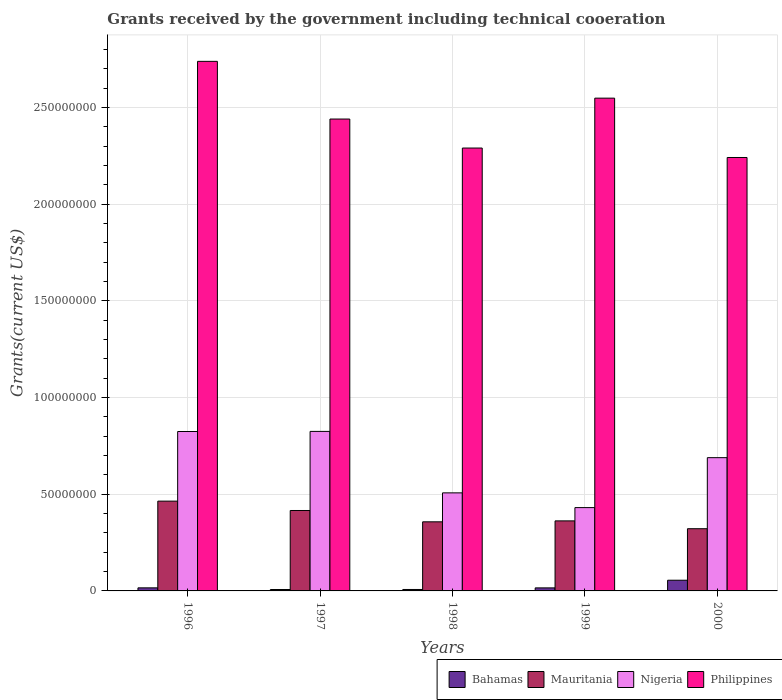How many groups of bars are there?
Provide a short and direct response. 5. Are the number of bars on each tick of the X-axis equal?
Ensure brevity in your answer.  Yes. How many bars are there on the 5th tick from the left?
Your answer should be compact. 4. How many bars are there on the 1st tick from the right?
Your answer should be very brief. 4. What is the label of the 1st group of bars from the left?
Give a very brief answer. 1996. What is the total grants received by the government in Mauritania in 1998?
Offer a terse response. 3.57e+07. Across all years, what is the maximum total grants received by the government in Mauritania?
Offer a very short reply. 4.64e+07. Across all years, what is the minimum total grants received by the government in Nigeria?
Keep it short and to the point. 4.31e+07. In which year was the total grants received by the government in Philippines maximum?
Ensure brevity in your answer.  1996. In which year was the total grants received by the government in Bahamas minimum?
Ensure brevity in your answer.  1997. What is the total total grants received by the government in Nigeria in the graph?
Offer a very short reply. 3.28e+08. What is the difference between the total grants received by the government in Mauritania in 1997 and that in 1999?
Provide a succinct answer. 5.37e+06. What is the difference between the total grants received by the government in Mauritania in 1998 and the total grants received by the government in Philippines in 1996?
Your response must be concise. -2.38e+08. What is the average total grants received by the government in Philippines per year?
Offer a very short reply. 2.45e+08. In the year 1996, what is the difference between the total grants received by the government in Bahamas and total grants received by the government in Mauritania?
Ensure brevity in your answer.  -4.48e+07. What is the ratio of the total grants received by the government in Mauritania in 1996 to that in 1998?
Provide a succinct answer. 1.3. Is the total grants received by the government in Philippines in 1996 less than that in 1999?
Provide a short and direct response. No. What is the difference between the highest and the second highest total grants received by the government in Bahamas?
Give a very brief answer. 3.94e+06. What is the difference between the highest and the lowest total grants received by the government in Bahamas?
Your response must be concise. 4.80e+06. Is the sum of the total grants received by the government in Bahamas in 1997 and 1999 greater than the maximum total grants received by the government in Nigeria across all years?
Ensure brevity in your answer.  No. Is it the case that in every year, the sum of the total grants received by the government in Mauritania and total grants received by the government in Bahamas is greater than the sum of total grants received by the government in Nigeria and total grants received by the government in Philippines?
Offer a terse response. No. What does the 3rd bar from the left in 1998 represents?
Make the answer very short. Nigeria. What does the 2nd bar from the right in 1998 represents?
Your answer should be compact. Nigeria. Are all the bars in the graph horizontal?
Keep it short and to the point. No. How many years are there in the graph?
Make the answer very short. 5. Are the values on the major ticks of Y-axis written in scientific E-notation?
Your answer should be very brief. No. How many legend labels are there?
Keep it short and to the point. 4. What is the title of the graph?
Provide a short and direct response. Grants received by the government including technical cooeration. Does "Solomon Islands" appear as one of the legend labels in the graph?
Your response must be concise. No. What is the label or title of the X-axis?
Give a very brief answer. Years. What is the label or title of the Y-axis?
Your answer should be very brief. Grants(current US$). What is the Grants(current US$) in Bahamas in 1996?
Your answer should be compact. 1.59e+06. What is the Grants(current US$) in Mauritania in 1996?
Keep it short and to the point. 4.64e+07. What is the Grants(current US$) of Nigeria in 1996?
Your response must be concise. 8.25e+07. What is the Grants(current US$) of Philippines in 1996?
Your answer should be very brief. 2.74e+08. What is the Grants(current US$) of Bahamas in 1997?
Make the answer very short. 7.30e+05. What is the Grants(current US$) in Mauritania in 1997?
Ensure brevity in your answer.  4.16e+07. What is the Grants(current US$) of Nigeria in 1997?
Provide a succinct answer. 8.25e+07. What is the Grants(current US$) in Philippines in 1997?
Provide a short and direct response. 2.44e+08. What is the Grants(current US$) of Bahamas in 1998?
Ensure brevity in your answer.  7.50e+05. What is the Grants(current US$) of Mauritania in 1998?
Your answer should be very brief. 3.57e+07. What is the Grants(current US$) of Nigeria in 1998?
Offer a very short reply. 5.07e+07. What is the Grants(current US$) of Philippines in 1998?
Your answer should be compact. 2.29e+08. What is the Grants(current US$) in Bahamas in 1999?
Offer a terse response. 1.57e+06. What is the Grants(current US$) of Mauritania in 1999?
Offer a terse response. 3.62e+07. What is the Grants(current US$) of Nigeria in 1999?
Give a very brief answer. 4.31e+07. What is the Grants(current US$) of Philippines in 1999?
Offer a terse response. 2.55e+08. What is the Grants(current US$) in Bahamas in 2000?
Your answer should be compact. 5.53e+06. What is the Grants(current US$) in Mauritania in 2000?
Your answer should be very brief. 3.22e+07. What is the Grants(current US$) of Nigeria in 2000?
Keep it short and to the point. 6.89e+07. What is the Grants(current US$) of Philippines in 2000?
Give a very brief answer. 2.24e+08. Across all years, what is the maximum Grants(current US$) of Bahamas?
Offer a very short reply. 5.53e+06. Across all years, what is the maximum Grants(current US$) of Mauritania?
Offer a terse response. 4.64e+07. Across all years, what is the maximum Grants(current US$) of Nigeria?
Ensure brevity in your answer.  8.25e+07. Across all years, what is the maximum Grants(current US$) of Philippines?
Your response must be concise. 2.74e+08. Across all years, what is the minimum Grants(current US$) in Bahamas?
Provide a succinct answer. 7.30e+05. Across all years, what is the minimum Grants(current US$) in Mauritania?
Your answer should be compact. 3.22e+07. Across all years, what is the minimum Grants(current US$) of Nigeria?
Give a very brief answer. 4.31e+07. Across all years, what is the minimum Grants(current US$) in Philippines?
Offer a very short reply. 2.24e+08. What is the total Grants(current US$) of Bahamas in the graph?
Offer a terse response. 1.02e+07. What is the total Grants(current US$) in Mauritania in the graph?
Make the answer very short. 1.92e+08. What is the total Grants(current US$) in Nigeria in the graph?
Your answer should be compact. 3.28e+08. What is the total Grants(current US$) of Philippines in the graph?
Your response must be concise. 1.23e+09. What is the difference between the Grants(current US$) of Bahamas in 1996 and that in 1997?
Give a very brief answer. 8.60e+05. What is the difference between the Grants(current US$) of Mauritania in 1996 and that in 1997?
Offer a very short reply. 4.84e+06. What is the difference between the Grants(current US$) in Nigeria in 1996 and that in 1997?
Provide a succinct answer. -5.00e+04. What is the difference between the Grants(current US$) of Philippines in 1996 and that in 1997?
Make the answer very short. 2.98e+07. What is the difference between the Grants(current US$) in Bahamas in 1996 and that in 1998?
Your answer should be compact. 8.40e+05. What is the difference between the Grants(current US$) in Mauritania in 1996 and that in 1998?
Your answer should be compact. 1.07e+07. What is the difference between the Grants(current US$) in Nigeria in 1996 and that in 1998?
Provide a succinct answer. 3.17e+07. What is the difference between the Grants(current US$) in Philippines in 1996 and that in 1998?
Offer a terse response. 4.48e+07. What is the difference between the Grants(current US$) of Mauritania in 1996 and that in 1999?
Your answer should be very brief. 1.02e+07. What is the difference between the Grants(current US$) of Nigeria in 1996 and that in 1999?
Give a very brief answer. 3.94e+07. What is the difference between the Grants(current US$) of Philippines in 1996 and that in 1999?
Your response must be concise. 1.90e+07. What is the difference between the Grants(current US$) in Bahamas in 1996 and that in 2000?
Make the answer very short. -3.94e+06. What is the difference between the Grants(current US$) of Mauritania in 1996 and that in 2000?
Make the answer very short. 1.43e+07. What is the difference between the Grants(current US$) in Nigeria in 1996 and that in 2000?
Provide a succinct answer. 1.35e+07. What is the difference between the Grants(current US$) in Philippines in 1996 and that in 2000?
Your response must be concise. 4.97e+07. What is the difference between the Grants(current US$) of Mauritania in 1997 and that in 1998?
Your answer should be very brief. 5.86e+06. What is the difference between the Grants(current US$) in Nigeria in 1997 and that in 1998?
Provide a succinct answer. 3.18e+07. What is the difference between the Grants(current US$) of Philippines in 1997 and that in 1998?
Your answer should be compact. 1.50e+07. What is the difference between the Grants(current US$) of Bahamas in 1997 and that in 1999?
Your response must be concise. -8.40e+05. What is the difference between the Grants(current US$) in Mauritania in 1997 and that in 1999?
Offer a terse response. 5.37e+06. What is the difference between the Grants(current US$) of Nigeria in 1997 and that in 1999?
Provide a short and direct response. 3.94e+07. What is the difference between the Grants(current US$) in Philippines in 1997 and that in 1999?
Ensure brevity in your answer.  -1.08e+07. What is the difference between the Grants(current US$) of Bahamas in 1997 and that in 2000?
Your answer should be compact. -4.80e+06. What is the difference between the Grants(current US$) of Mauritania in 1997 and that in 2000?
Provide a succinct answer. 9.42e+06. What is the difference between the Grants(current US$) in Nigeria in 1997 and that in 2000?
Ensure brevity in your answer.  1.36e+07. What is the difference between the Grants(current US$) of Philippines in 1997 and that in 2000?
Ensure brevity in your answer.  1.99e+07. What is the difference between the Grants(current US$) in Bahamas in 1998 and that in 1999?
Offer a very short reply. -8.20e+05. What is the difference between the Grants(current US$) in Mauritania in 1998 and that in 1999?
Make the answer very short. -4.90e+05. What is the difference between the Grants(current US$) of Nigeria in 1998 and that in 1999?
Your answer should be very brief. 7.62e+06. What is the difference between the Grants(current US$) in Philippines in 1998 and that in 1999?
Your response must be concise. -2.58e+07. What is the difference between the Grants(current US$) of Bahamas in 1998 and that in 2000?
Your response must be concise. -4.78e+06. What is the difference between the Grants(current US$) in Mauritania in 1998 and that in 2000?
Provide a succinct answer. 3.56e+06. What is the difference between the Grants(current US$) of Nigeria in 1998 and that in 2000?
Give a very brief answer. -1.82e+07. What is the difference between the Grants(current US$) in Philippines in 1998 and that in 2000?
Make the answer very short. 4.89e+06. What is the difference between the Grants(current US$) of Bahamas in 1999 and that in 2000?
Provide a succinct answer. -3.96e+06. What is the difference between the Grants(current US$) in Mauritania in 1999 and that in 2000?
Offer a terse response. 4.05e+06. What is the difference between the Grants(current US$) of Nigeria in 1999 and that in 2000?
Offer a very short reply. -2.58e+07. What is the difference between the Grants(current US$) in Philippines in 1999 and that in 2000?
Give a very brief answer. 3.07e+07. What is the difference between the Grants(current US$) in Bahamas in 1996 and the Grants(current US$) in Mauritania in 1997?
Give a very brief answer. -4.00e+07. What is the difference between the Grants(current US$) in Bahamas in 1996 and the Grants(current US$) in Nigeria in 1997?
Your response must be concise. -8.09e+07. What is the difference between the Grants(current US$) in Bahamas in 1996 and the Grants(current US$) in Philippines in 1997?
Give a very brief answer. -2.42e+08. What is the difference between the Grants(current US$) of Mauritania in 1996 and the Grants(current US$) of Nigeria in 1997?
Make the answer very short. -3.61e+07. What is the difference between the Grants(current US$) of Mauritania in 1996 and the Grants(current US$) of Philippines in 1997?
Offer a terse response. -1.98e+08. What is the difference between the Grants(current US$) in Nigeria in 1996 and the Grants(current US$) in Philippines in 1997?
Your answer should be very brief. -1.62e+08. What is the difference between the Grants(current US$) of Bahamas in 1996 and the Grants(current US$) of Mauritania in 1998?
Your answer should be very brief. -3.42e+07. What is the difference between the Grants(current US$) in Bahamas in 1996 and the Grants(current US$) in Nigeria in 1998?
Ensure brevity in your answer.  -4.91e+07. What is the difference between the Grants(current US$) of Bahamas in 1996 and the Grants(current US$) of Philippines in 1998?
Provide a short and direct response. -2.27e+08. What is the difference between the Grants(current US$) in Mauritania in 1996 and the Grants(current US$) in Nigeria in 1998?
Ensure brevity in your answer.  -4.28e+06. What is the difference between the Grants(current US$) in Mauritania in 1996 and the Grants(current US$) in Philippines in 1998?
Provide a short and direct response. -1.83e+08. What is the difference between the Grants(current US$) of Nigeria in 1996 and the Grants(current US$) of Philippines in 1998?
Keep it short and to the point. -1.47e+08. What is the difference between the Grants(current US$) of Bahamas in 1996 and the Grants(current US$) of Mauritania in 1999?
Offer a very short reply. -3.46e+07. What is the difference between the Grants(current US$) in Bahamas in 1996 and the Grants(current US$) in Nigeria in 1999?
Provide a succinct answer. -4.15e+07. What is the difference between the Grants(current US$) in Bahamas in 1996 and the Grants(current US$) in Philippines in 1999?
Your answer should be compact. -2.53e+08. What is the difference between the Grants(current US$) of Mauritania in 1996 and the Grants(current US$) of Nigeria in 1999?
Make the answer very short. 3.34e+06. What is the difference between the Grants(current US$) in Mauritania in 1996 and the Grants(current US$) in Philippines in 1999?
Offer a very short reply. -2.08e+08. What is the difference between the Grants(current US$) in Nigeria in 1996 and the Grants(current US$) in Philippines in 1999?
Your answer should be compact. -1.72e+08. What is the difference between the Grants(current US$) of Bahamas in 1996 and the Grants(current US$) of Mauritania in 2000?
Give a very brief answer. -3.06e+07. What is the difference between the Grants(current US$) in Bahamas in 1996 and the Grants(current US$) in Nigeria in 2000?
Offer a terse response. -6.73e+07. What is the difference between the Grants(current US$) of Bahamas in 1996 and the Grants(current US$) of Philippines in 2000?
Provide a short and direct response. -2.23e+08. What is the difference between the Grants(current US$) in Mauritania in 1996 and the Grants(current US$) in Nigeria in 2000?
Give a very brief answer. -2.25e+07. What is the difference between the Grants(current US$) in Mauritania in 1996 and the Grants(current US$) in Philippines in 2000?
Your answer should be very brief. -1.78e+08. What is the difference between the Grants(current US$) of Nigeria in 1996 and the Grants(current US$) of Philippines in 2000?
Your answer should be very brief. -1.42e+08. What is the difference between the Grants(current US$) of Bahamas in 1997 and the Grants(current US$) of Mauritania in 1998?
Ensure brevity in your answer.  -3.50e+07. What is the difference between the Grants(current US$) in Bahamas in 1997 and the Grants(current US$) in Nigeria in 1998?
Provide a succinct answer. -5.00e+07. What is the difference between the Grants(current US$) in Bahamas in 1997 and the Grants(current US$) in Philippines in 1998?
Make the answer very short. -2.28e+08. What is the difference between the Grants(current US$) in Mauritania in 1997 and the Grants(current US$) in Nigeria in 1998?
Offer a very short reply. -9.12e+06. What is the difference between the Grants(current US$) of Mauritania in 1997 and the Grants(current US$) of Philippines in 1998?
Provide a short and direct response. -1.87e+08. What is the difference between the Grants(current US$) in Nigeria in 1997 and the Grants(current US$) in Philippines in 1998?
Provide a short and direct response. -1.47e+08. What is the difference between the Grants(current US$) in Bahamas in 1997 and the Grants(current US$) in Mauritania in 1999?
Ensure brevity in your answer.  -3.55e+07. What is the difference between the Grants(current US$) in Bahamas in 1997 and the Grants(current US$) in Nigeria in 1999?
Make the answer very short. -4.24e+07. What is the difference between the Grants(current US$) of Bahamas in 1997 and the Grants(current US$) of Philippines in 1999?
Give a very brief answer. -2.54e+08. What is the difference between the Grants(current US$) in Mauritania in 1997 and the Grants(current US$) in Nigeria in 1999?
Provide a succinct answer. -1.50e+06. What is the difference between the Grants(current US$) in Mauritania in 1997 and the Grants(current US$) in Philippines in 1999?
Offer a terse response. -2.13e+08. What is the difference between the Grants(current US$) in Nigeria in 1997 and the Grants(current US$) in Philippines in 1999?
Your answer should be very brief. -1.72e+08. What is the difference between the Grants(current US$) of Bahamas in 1997 and the Grants(current US$) of Mauritania in 2000?
Your response must be concise. -3.14e+07. What is the difference between the Grants(current US$) of Bahamas in 1997 and the Grants(current US$) of Nigeria in 2000?
Your response must be concise. -6.82e+07. What is the difference between the Grants(current US$) in Bahamas in 1997 and the Grants(current US$) in Philippines in 2000?
Your answer should be very brief. -2.23e+08. What is the difference between the Grants(current US$) in Mauritania in 1997 and the Grants(current US$) in Nigeria in 2000?
Give a very brief answer. -2.73e+07. What is the difference between the Grants(current US$) in Mauritania in 1997 and the Grants(current US$) in Philippines in 2000?
Offer a terse response. -1.83e+08. What is the difference between the Grants(current US$) of Nigeria in 1997 and the Grants(current US$) of Philippines in 2000?
Provide a succinct answer. -1.42e+08. What is the difference between the Grants(current US$) of Bahamas in 1998 and the Grants(current US$) of Mauritania in 1999?
Offer a very short reply. -3.55e+07. What is the difference between the Grants(current US$) in Bahamas in 1998 and the Grants(current US$) in Nigeria in 1999?
Offer a very short reply. -4.24e+07. What is the difference between the Grants(current US$) of Bahamas in 1998 and the Grants(current US$) of Philippines in 1999?
Your answer should be compact. -2.54e+08. What is the difference between the Grants(current US$) in Mauritania in 1998 and the Grants(current US$) in Nigeria in 1999?
Provide a short and direct response. -7.36e+06. What is the difference between the Grants(current US$) of Mauritania in 1998 and the Grants(current US$) of Philippines in 1999?
Offer a very short reply. -2.19e+08. What is the difference between the Grants(current US$) in Nigeria in 1998 and the Grants(current US$) in Philippines in 1999?
Your response must be concise. -2.04e+08. What is the difference between the Grants(current US$) in Bahamas in 1998 and the Grants(current US$) in Mauritania in 2000?
Offer a terse response. -3.14e+07. What is the difference between the Grants(current US$) in Bahamas in 1998 and the Grants(current US$) in Nigeria in 2000?
Offer a terse response. -6.82e+07. What is the difference between the Grants(current US$) of Bahamas in 1998 and the Grants(current US$) of Philippines in 2000?
Provide a short and direct response. -2.23e+08. What is the difference between the Grants(current US$) in Mauritania in 1998 and the Grants(current US$) in Nigeria in 2000?
Ensure brevity in your answer.  -3.32e+07. What is the difference between the Grants(current US$) in Mauritania in 1998 and the Grants(current US$) in Philippines in 2000?
Keep it short and to the point. -1.88e+08. What is the difference between the Grants(current US$) of Nigeria in 1998 and the Grants(current US$) of Philippines in 2000?
Ensure brevity in your answer.  -1.73e+08. What is the difference between the Grants(current US$) in Bahamas in 1999 and the Grants(current US$) in Mauritania in 2000?
Keep it short and to the point. -3.06e+07. What is the difference between the Grants(current US$) of Bahamas in 1999 and the Grants(current US$) of Nigeria in 2000?
Your answer should be compact. -6.74e+07. What is the difference between the Grants(current US$) in Bahamas in 1999 and the Grants(current US$) in Philippines in 2000?
Ensure brevity in your answer.  -2.23e+08. What is the difference between the Grants(current US$) in Mauritania in 1999 and the Grants(current US$) in Nigeria in 2000?
Offer a terse response. -3.27e+07. What is the difference between the Grants(current US$) in Mauritania in 1999 and the Grants(current US$) in Philippines in 2000?
Ensure brevity in your answer.  -1.88e+08. What is the difference between the Grants(current US$) of Nigeria in 1999 and the Grants(current US$) of Philippines in 2000?
Offer a very short reply. -1.81e+08. What is the average Grants(current US$) of Bahamas per year?
Make the answer very short. 2.03e+06. What is the average Grants(current US$) in Mauritania per year?
Make the answer very short. 3.84e+07. What is the average Grants(current US$) in Nigeria per year?
Provide a succinct answer. 6.55e+07. What is the average Grants(current US$) in Philippines per year?
Keep it short and to the point. 2.45e+08. In the year 1996, what is the difference between the Grants(current US$) of Bahamas and Grants(current US$) of Mauritania?
Your answer should be compact. -4.48e+07. In the year 1996, what is the difference between the Grants(current US$) of Bahamas and Grants(current US$) of Nigeria?
Provide a succinct answer. -8.09e+07. In the year 1996, what is the difference between the Grants(current US$) in Bahamas and Grants(current US$) in Philippines?
Offer a terse response. -2.72e+08. In the year 1996, what is the difference between the Grants(current US$) of Mauritania and Grants(current US$) of Nigeria?
Make the answer very short. -3.60e+07. In the year 1996, what is the difference between the Grants(current US$) in Mauritania and Grants(current US$) in Philippines?
Provide a succinct answer. -2.27e+08. In the year 1996, what is the difference between the Grants(current US$) in Nigeria and Grants(current US$) in Philippines?
Keep it short and to the point. -1.91e+08. In the year 1997, what is the difference between the Grants(current US$) of Bahamas and Grants(current US$) of Mauritania?
Provide a short and direct response. -4.09e+07. In the year 1997, what is the difference between the Grants(current US$) in Bahamas and Grants(current US$) in Nigeria?
Provide a short and direct response. -8.18e+07. In the year 1997, what is the difference between the Grants(current US$) of Bahamas and Grants(current US$) of Philippines?
Ensure brevity in your answer.  -2.43e+08. In the year 1997, what is the difference between the Grants(current US$) of Mauritania and Grants(current US$) of Nigeria?
Offer a very short reply. -4.09e+07. In the year 1997, what is the difference between the Grants(current US$) of Mauritania and Grants(current US$) of Philippines?
Give a very brief answer. -2.02e+08. In the year 1997, what is the difference between the Grants(current US$) in Nigeria and Grants(current US$) in Philippines?
Your answer should be compact. -1.62e+08. In the year 1998, what is the difference between the Grants(current US$) of Bahamas and Grants(current US$) of Mauritania?
Your answer should be compact. -3.50e+07. In the year 1998, what is the difference between the Grants(current US$) of Bahamas and Grants(current US$) of Nigeria?
Provide a succinct answer. -5.00e+07. In the year 1998, what is the difference between the Grants(current US$) of Bahamas and Grants(current US$) of Philippines?
Provide a succinct answer. -2.28e+08. In the year 1998, what is the difference between the Grants(current US$) in Mauritania and Grants(current US$) in Nigeria?
Your response must be concise. -1.50e+07. In the year 1998, what is the difference between the Grants(current US$) of Mauritania and Grants(current US$) of Philippines?
Ensure brevity in your answer.  -1.93e+08. In the year 1998, what is the difference between the Grants(current US$) in Nigeria and Grants(current US$) in Philippines?
Provide a succinct answer. -1.78e+08. In the year 1999, what is the difference between the Grants(current US$) of Bahamas and Grants(current US$) of Mauritania?
Ensure brevity in your answer.  -3.47e+07. In the year 1999, what is the difference between the Grants(current US$) of Bahamas and Grants(current US$) of Nigeria?
Your answer should be compact. -4.15e+07. In the year 1999, what is the difference between the Grants(current US$) in Bahamas and Grants(current US$) in Philippines?
Offer a terse response. -2.53e+08. In the year 1999, what is the difference between the Grants(current US$) in Mauritania and Grants(current US$) in Nigeria?
Keep it short and to the point. -6.87e+06. In the year 1999, what is the difference between the Grants(current US$) in Mauritania and Grants(current US$) in Philippines?
Offer a very short reply. -2.19e+08. In the year 1999, what is the difference between the Grants(current US$) in Nigeria and Grants(current US$) in Philippines?
Your answer should be compact. -2.12e+08. In the year 2000, what is the difference between the Grants(current US$) of Bahamas and Grants(current US$) of Mauritania?
Offer a terse response. -2.66e+07. In the year 2000, what is the difference between the Grants(current US$) of Bahamas and Grants(current US$) of Nigeria?
Give a very brief answer. -6.34e+07. In the year 2000, what is the difference between the Grants(current US$) of Bahamas and Grants(current US$) of Philippines?
Provide a short and direct response. -2.19e+08. In the year 2000, what is the difference between the Grants(current US$) of Mauritania and Grants(current US$) of Nigeria?
Ensure brevity in your answer.  -3.68e+07. In the year 2000, what is the difference between the Grants(current US$) of Mauritania and Grants(current US$) of Philippines?
Your answer should be very brief. -1.92e+08. In the year 2000, what is the difference between the Grants(current US$) in Nigeria and Grants(current US$) in Philippines?
Make the answer very short. -1.55e+08. What is the ratio of the Grants(current US$) of Bahamas in 1996 to that in 1997?
Provide a succinct answer. 2.18. What is the ratio of the Grants(current US$) in Mauritania in 1996 to that in 1997?
Offer a very short reply. 1.12. What is the ratio of the Grants(current US$) of Philippines in 1996 to that in 1997?
Your answer should be very brief. 1.12. What is the ratio of the Grants(current US$) in Bahamas in 1996 to that in 1998?
Your answer should be compact. 2.12. What is the ratio of the Grants(current US$) of Mauritania in 1996 to that in 1998?
Keep it short and to the point. 1.3. What is the ratio of the Grants(current US$) of Nigeria in 1996 to that in 1998?
Provide a succinct answer. 1.63. What is the ratio of the Grants(current US$) of Philippines in 1996 to that in 1998?
Ensure brevity in your answer.  1.2. What is the ratio of the Grants(current US$) in Bahamas in 1996 to that in 1999?
Give a very brief answer. 1.01. What is the ratio of the Grants(current US$) of Mauritania in 1996 to that in 1999?
Offer a very short reply. 1.28. What is the ratio of the Grants(current US$) in Nigeria in 1996 to that in 1999?
Keep it short and to the point. 1.91. What is the ratio of the Grants(current US$) of Philippines in 1996 to that in 1999?
Ensure brevity in your answer.  1.07. What is the ratio of the Grants(current US$) of Bahamas in 1996 to that in 2000?
Provide a short and direct response. 0.29. What is the ratio of the Grants(current US$) in Mauritania in 1996 to that in 2000?
Provide a succinct answer. 1.44. What is the ratio of the Grants(current US$) in Nigeria in 1996 to that in 2000?
Ensure brevity in your answer.  1.2. What is the ratio of the Grants(current US$) in Philippines in 1996 to that in 2000?
Your answer should be compact. 1.22. What is the ratio of the Grants(current US$) in Bahamas in 1997 to that in 1998?
Provide a succinct answer. 0.97. What is the ratio of the Grants(current US$) in Mauritania in 1997 to that in 1998?
Your answer should be very brief. 1.16. What is the ratio of the Grants(current US$) of Nigeria in 1997 to that in 1998?
Make the answer very short. 1.63. What is the ratio of the Grants(current US$) of Philippines in 1997 to that in 1998?
Ensure brevity in your answer.  1.07. What is the ratio of the Grants(current US$) of Bahamas in 1997 to that in 1999?
Offer a very short reply. 0.47. What is the ratio of the Grants(current US$) in Mauritania in 1997 to that in 1999?
Your answer should be very brief. 1.15. What is the ratio of the Grants(current US$) of Nigeria in 1997 to that in 1999?
Provide a succinct answer. 1.91. What is the ratio of the Grants(current US$) in Philippines in 1997 to that in 1999?
Keep it short and to the point. 0.96. What is the ratio of the Grants(current US$) in Bahamas in 1997 to that in 2000?
Make the answer very short. 0.13. What is the ratio of the Grants(current US$) in Mauritania in 1997 to that in 2000?
Make the answer very short. 1.29. What is the ratio of the Grants(current US$) in Nigeria in 1997 to that in 2000?
Make the answer very short. 1.2. What is the ratio of the Grants(current US$) of Philippines in 1997 to that in 2000?
Provide a succinct answer. 1.09. What is the ratio of the Grants(current US$) in Bahamas in 1998 to that in 1999?
Make the answer very short. 0.48. What is the ratio of the Grants(current US$) of Mauritania in 1998 to that in 1999?
Provide a succinct answer. 0.99. What is the ratio of the Grants(current US$) in Nigeria in 1998 to that in 1999?
Your response must be concise. 1.18. What is the ratio of the Grants(current US$) in Philippines in 1998 to that in 1999?
Your answer should be very brief. 0.9. What is the ratio of the Grants(current US$) of Bahamas in 1998 to that in 2000?
Provide a succinct answer. 0.14. What is the ratio of the Grants(current US$) in Mauritania in 1998 to that in 2000?
Provide a succinct answer. 1.11. What is the ratio of the Grants(current US$) of Nigeria in 1998 to that in 2000?
Your response must be concise. 0.74. What is the ratio of the Grants(current US$) in Philippines in 1998 to that in 2000?
Provide a succinct answer. 1.02. What is the ratio of the Grants(current US$) of Bahamas in 1999 to that in 2000?
Provide a succinct answer. 0.28. What is the ratio of the Grants(current US$) of Mauritania in 1999 to that in 2000?
Your answer should be very brief. 1.13. What is the ratio of the Grants(current US$) of Nigeria in 1999 to that in 2000?
Your response must be concise. 0.63. What is the ratio of the Grants(current US$) of Philippines in 1999 to that in 2000?
Offer a very short reply. 1.14. What is the difference between the highest and the second highest Grants(current US$) in Bahamas?
Provide a short and direct response. 3.94e+06. What is the difference between the highest and the second highest Grants(current US$) in Mauritania?
Offer a very short reply. 4.84e+06. What is the difference between the highest and the second highest Grants(current US$) of Nigeria?
Your answer should be compact. 5.00e+04. What is the difference between the highest and the second highest Grants(current US$) in Philippines?
Keep it short and to the point. 1.90e+07. What is the difference between the highest and the lowest Grants(current US$) of Bahamas?
Provide a short and direct response. 4.80e+06. What is the difference between the highest and the lowest Grants(current US$) of Mauritania?
Provide a succinct answer. 1.43e+07. What is the difference between the highest and the lowest Grants(current US$) in Nigeria?
Your answer should be compact. 3.94e+07. What is the difference between the highest and the lowest Grants(current US$) of Philippines?
Provide a short and direct response. 4.97e+07. 